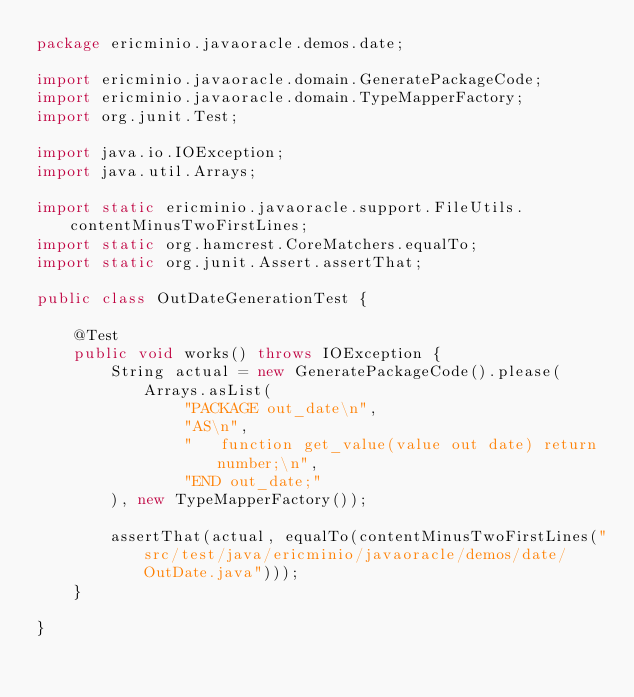<code> <loc_0><loc_0><loc_500><loc_500><_Java_>package ericminio.javaoracle.demos.date;

import ericminio.javaoracle.domain.GeneratePackageCode;
import ericminio.javaoracle.domain.TypeMapperFactory;
import org.junit.Test;

import java.io.IOException;
import java.util.Arrays;

import static ericminio.javaoracle.support.FileUtils.contentMinusTwoFirstLines;
import static org.hamcrest.CoreMatchers.equalTo;
import static org.junit.Assert.assertThat;

public class OutDateGenerationTest {

    @Test
    public void works() throws IOException {
        String actual = new GeneratePackageCode().please(Arrays.asList(
                "PACKAGE out_date\n",
                "AS\n",
                "   function get_value(value out date) return number;\n",
                "END out_date;"
        ), new TypeMapperFactory());
        
        assertThat(actual, equalTo(contentMinusTwoFirstLines("src/test/java/ericminio/javaoracle/demos/date/OutDate.java")));
    }

}</code> 